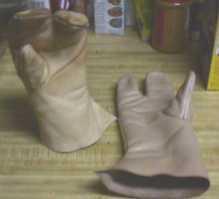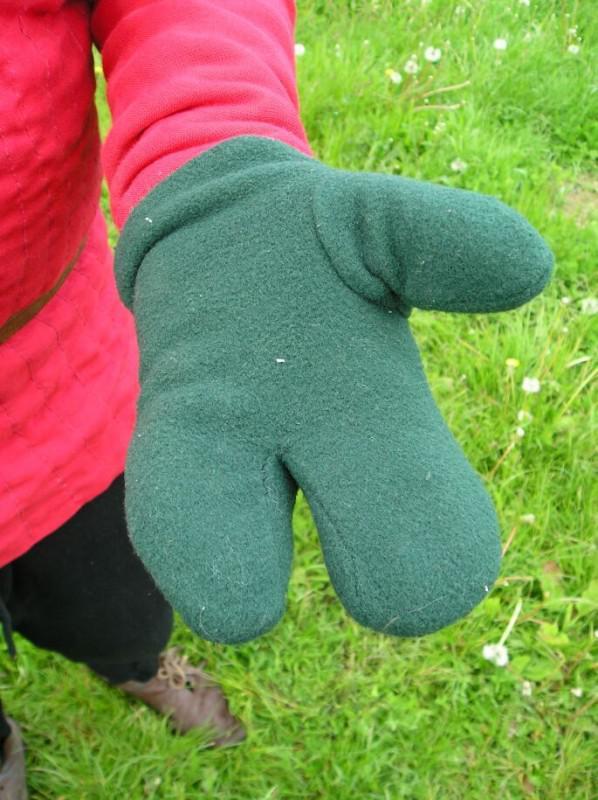The first image is the image on the left, the second image is the image on the right. Examine the images to the left and right. Is the description "only ONE of the sets of gloves is green." accurate? Answer yes or no. Yes. 